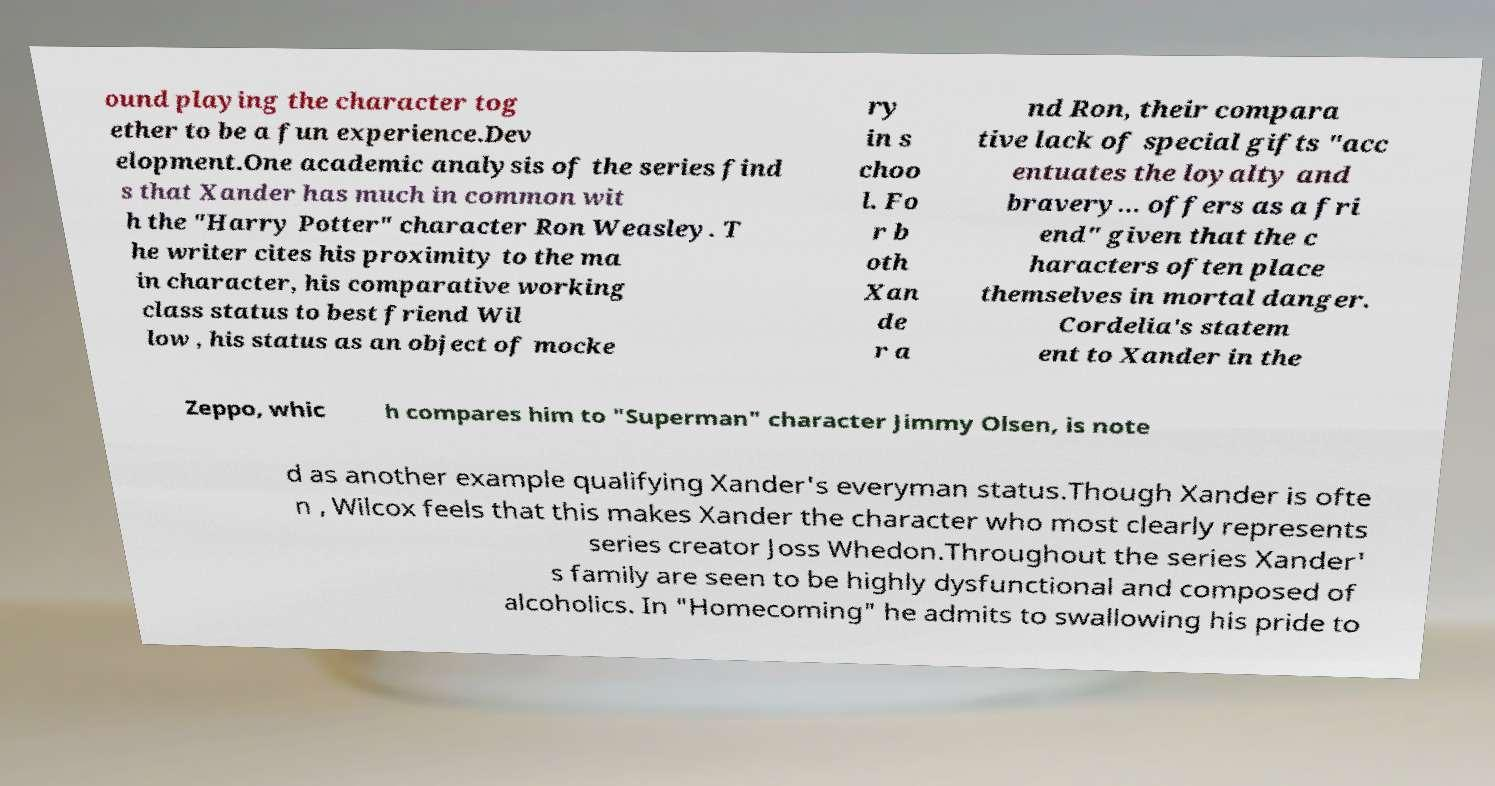For documentation purposes, I need the text within this image transcribed. Could you provide that? ound playing the character tog ether to be a fun experience.Dev elopment.One academic analysis of the series find s that Xander has much in common wit h the "Harry Potter" character Ron Weasley. T he writer cites his proximity to the ma in character, his comparative working class status to best friend Wil low , his status as an object of mocke ry in s choo l. Fo r b oth Xan de r a nd Ron, their compara tive lack of special gifts "acc entuates the loyalty and bravery... offers as a fri end" given that the c haracters often place themselves in mortal danger. Cordelia's statem ent to Xander in the Zeppo, whic h compares him to "Superman" character Jimmy Olsen, is note d as another example qualifying Xander's everyman status.Though Xander is ofte n , Wilcox feels that this makes Xander the character who most clearly represents series creator Joss Whedon.Throughout the series Xander' s family are seen to be highly dysfunctional and composed of alcoholics. In "Homecoming" he admits to swallowing his pride to 